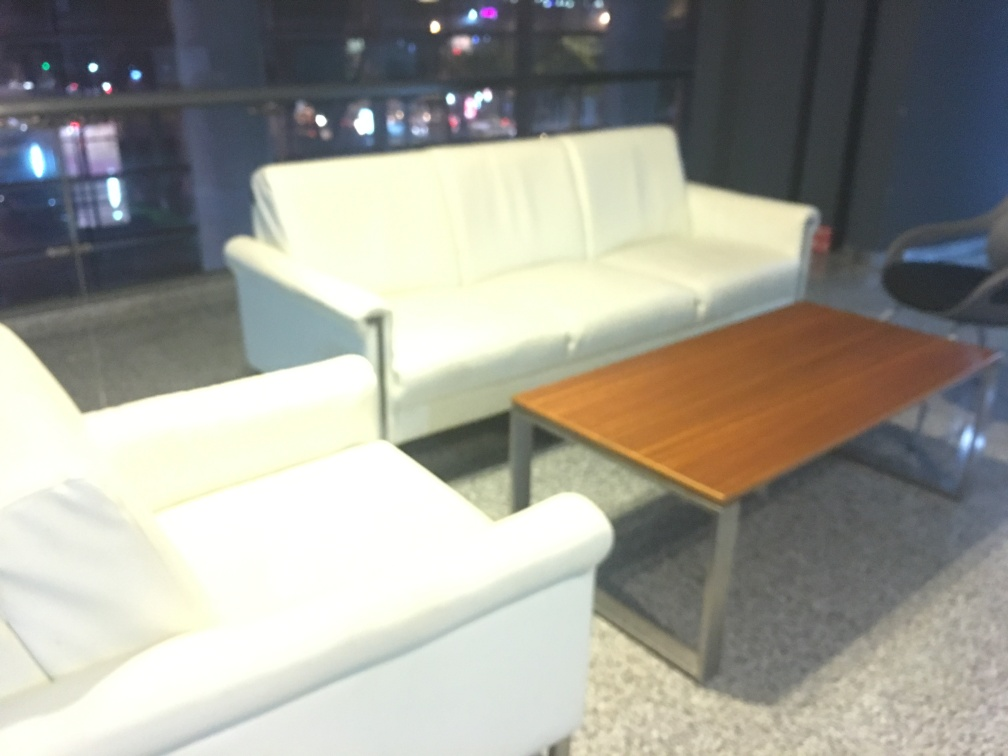How is the lighting in the image? A. Weak B. Strong C. Natural Answer with the option's letter from the given choices directly. The lighting in the image appears to be natural, as suggested by the soft highlights and gentle shadows present. It seems to emulate the ambiance of indoor lighting that possibly comes from nearby lamps or ambient light sources within the room. The mild intensity of light on the furniture indicates it is not overly strong, contributing to a subdued and calm atmosphere. Therefore, a more accurate answer would be 'C. Natural.' 